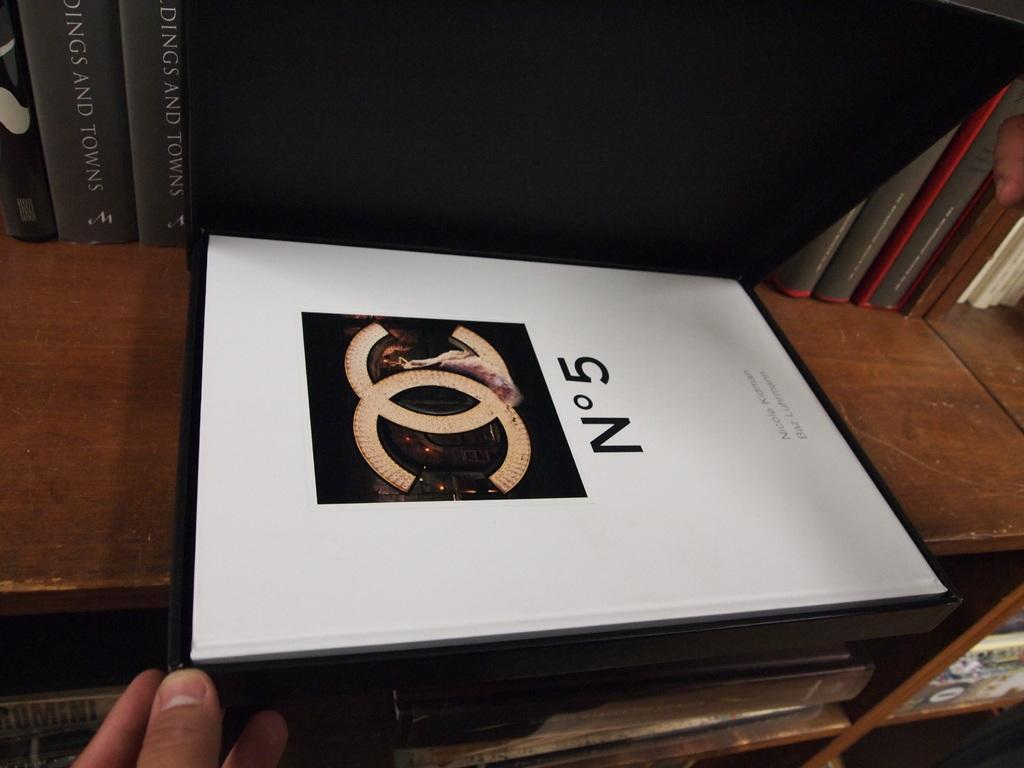<image>
Render a clear and concise summary of the photo. A person is holding a book on a shelf that has No 5 on it. 